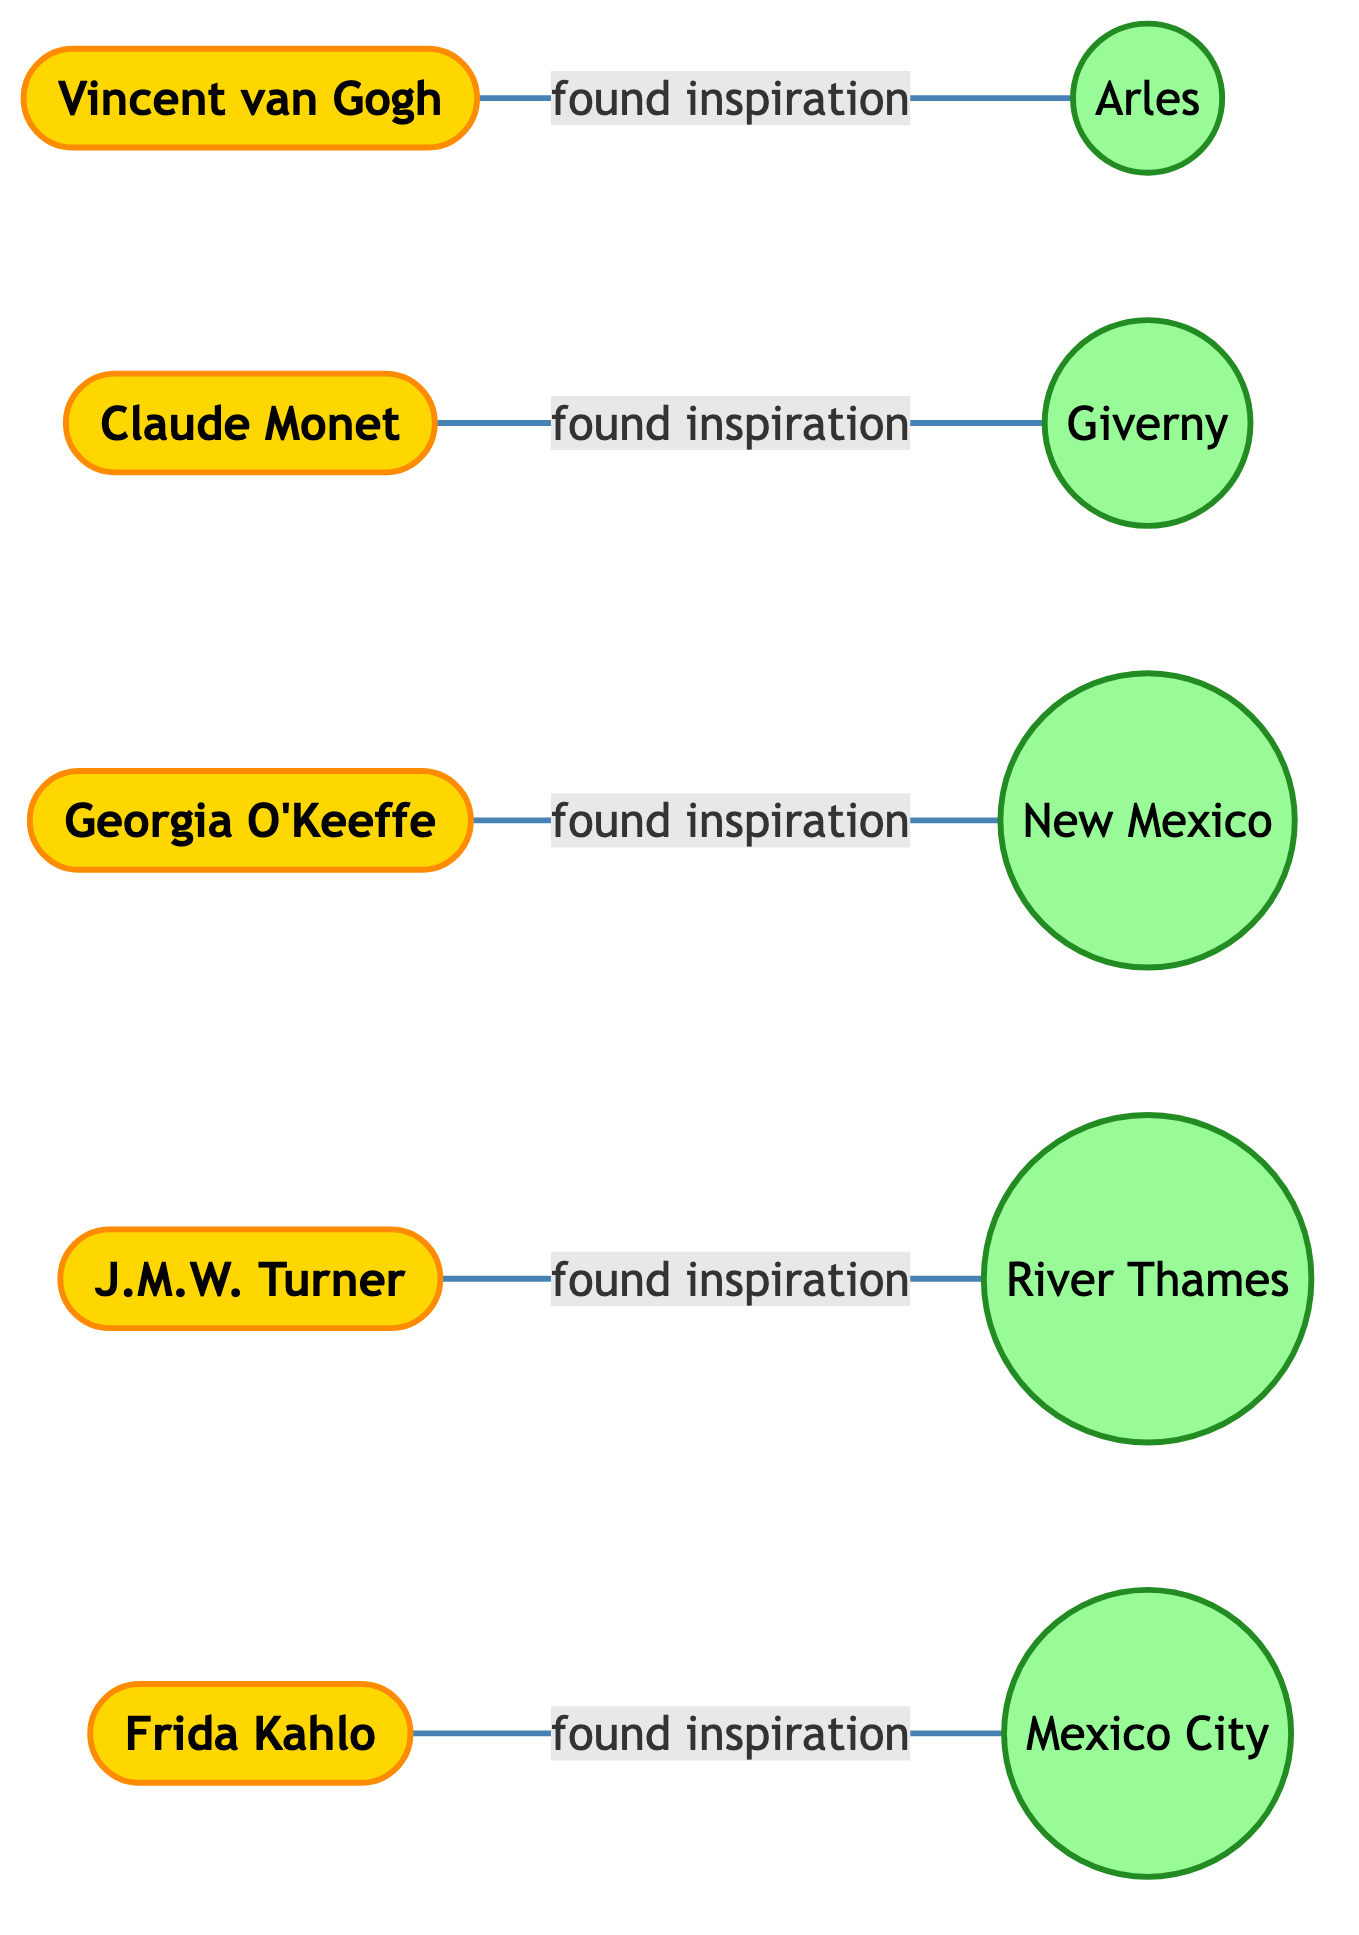What artist found inspiration in Arles? According to the edges in the diagram, Vincent van Gogh is linked to Arles with the label "found inspiration." Thus, the artist who found inspiration in Arles is Vincent van Gogh.
Answer: Vincent van Gogh What is the preferred natural location for Claude Monet? The diagram shows a direct connection between Claude Monet and Giverny, indicating that Giverny is his preferred natural location for inspiration.
Answer: Giverny How many artists are represented in the diagram? By counting the nodes categorized under artists, we can see there are five distinct artists (Vincent van Gogh, Claude Monet, Georgia O'Keeffe, J.M.W. Turner, Frida Kahlo).
Answer: 5 Which artist is connected to New Mexico? The connection between Georgia O'Keeffe and New Mexico is indicated in the diagram through the "found inspiration" relationship, identifying the artist related to New Mexico as Georgia O'Keeffe.
Answer: Georgia O'Keeffe What connects J.M.W. Turner to River Thames? The diagram shows that J.M.W. Turner is directly linked to River Thames with the label "found inspiration," indicating the nature of their connection.
Answer: found inspiration Which locations have no direct links to artists? Upon reviewing the nodes and edges, all locations listed (Arles, Giverny, New Mexico, River Thames, and Mexico City) are connected to artists. Therefore, no locations are without direct links.
Answer: None What is the total number of edges in the diagram? By counting each connection represented in the edges, we can see that there are a total of five edges connecting the artists to their preferred locations.
Answer: 5 Which artist is connected to Mexico City? Examining the edges, Frida Kahlo is linked to Mexico City with the label "found inspiration," establishing her connection to that particular location.
Answer: Frida Kahlo Is there a common location between any two artists in the diagram? Reviewing the connections, each artist is linked to a unique location with no shared connections, meaning there are no common locations between two artists in the diagram.
Answer: No 